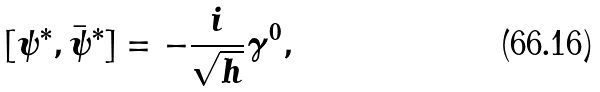Convert formula to latex. <formula><loc_0><loc_0><loc_500><loc_500>[ \psi ^ { * } , \bar { \psi } ^ { * } ] = - \frac { i } { \sqrt { h } } \gamma ^ { 0 } ,</formula> 